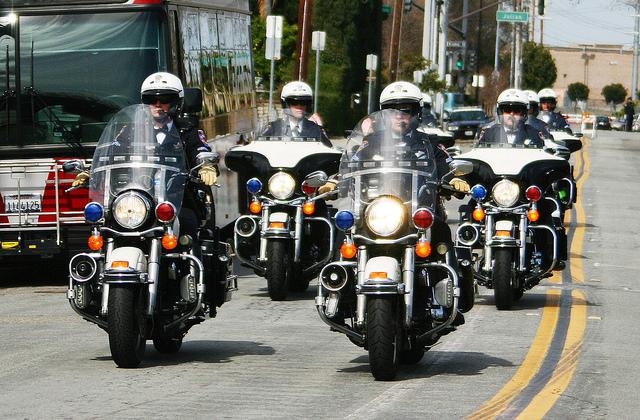How many police bikes are pictured?
Give a very brief answer. 6. What are the policemen escorting?
Keep it brief. Bus. Do the bikes have their lights on?
Short answer required. Yes. Are all of the motorcycles alike?
Quick response, please. Yes. 